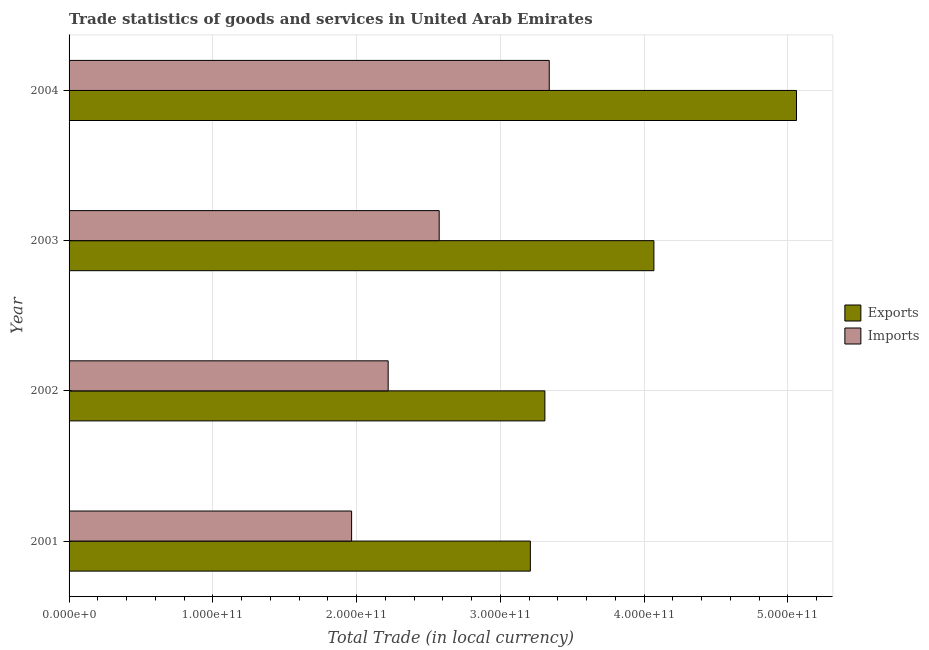Are the number of bars per tick equal to the number of legend labels?
Provide a succinct answer. Yes. In how many cases, is the number of bars for a given year not equal to the number of legend labels?
Your answer should be compact. 0. What is the imports of goods and services in 2003?
Your answer should be compact. 2.57e+11. Across all years, what is the maximum export of goods and services?
Offer a terse response. 5.06e+11. Across all years, what is the minimum imports of goods and services?
Ensure brevity in your answer.  1.97e+11. In which year was the export of goods and services maximum?
Your response must be concise. 2004. In which year was the export of goods and services minimum?
Provide a succinct answer. 2001. What is the total imports of goods and services in the graph?
Offer a terse response. 1.01e+12. What is the difference between the export of goods and services in 2002 and that in 2004?
Your answer should be very brief. -1.75e+11. What is the difference between the export of goods and services in 2002 and the imports of goods and services in 2004?
Provide a short and direct response. -3.03e+09. What is the average export of goods and services per year?
Provide a succinct answer. 3.91e+11. In the year 2003, what is the difference between the imports of goods and services and export of goods and services?
Provide a succinct answer. -1.49e+11. In how many years, is the imports of goods and services greater than 300000000000 LCU?
Your answer should be compact. 1. What is the ratio of the imports of goods and services in 2002 to that in 2004?
Your answer should be compact. 0.67. Is the imports of goods and services in 2002 less than that in 2004?
Keep it short and to the point. Yes. Is the difference between the imports of goods and services in 2003 and 2004 greater than the difference between the export of goods and services in 2003 and 2004?
Ensure brevity in your answer.  Yes. What is the difference between the highest and the second highest export of goods and services?
Your answer should be very brief. 9.92e+1. What is the difference between the highest and the lowest imports of goods and services?
Ensure brevity in your answer.  1.37e+11. What does the 1st bar from the top in 2004 represents?
Ensure brevity in your answer.  Imports. What does the 1st bar from the bottom in 2003 represents?
Ensure brevity in your answer.  Exports. What is the difference between two consecutive major ticks on the X-axis?
Ensure brevity in your answer.  1.00e+11. Does the graph contain any zero values?
Your answer should be compact. No. Does the graph contain grids?
Offer a very short reply. Yes. How are the legend labels stacked?
Offer a terse response. Vertical. What is the title of the graph?
Offer a very short reply. Trade statistics of goods and services in United Arab Emirates. What is the label or title of the X-axis?
Keep it short and to the point. Total Trade (in local currency). What is the Total Trade (in local currency) in Exports in 2001?
Your answer should be very brief. 3.21e+11. What is the Total Trade (in local currency) of Imports in 2001?
Your answer should be compact. 1.97e+11. What is the Total Trade (in local currency) of Exports in 2002?
Your response must be concise. 3.31e+11. What is the Total Trade (in local currency) of Imports in 2002?
Give a very brief answer. 2.22e+11. What is the Total Trade (in local currency) of Exports in 2003?
Provide a short and direct response. 4.07e+11. What is the Total Trade (in local currency) of Imports in 2003?
Give a very brief answer. 2.57e+11. What is the Total Trade (in local currency) of Exports in 2004?
Make the answer very short. 5.06e+11. What is the Total Trade (in local currency) of Imports in 2004?
Ensure brevity in your answer.  3.34e+11. Across all years, what is the maximum Total Trade (in local currency) in Exports?
Keep it short and to the point. 5.06e+11. Across all years, what is the maximum Total Trade (in local currency) of Imports?
Offer a terse response. 3.34e+11. Across all years, what is the minimum Total Trade (in local currency) in Exports?
Provide a short and direct response. 3.21e+11. Across all years, what is the minimum Total Trade (in local currency) in Imports?
Make the answer very short. 1.97e+11. What is the total Total Trade (in local currency) of Exports in the graph?
Offer a terse response. 1.56e+12. What is the total Total Trade (in local currency) in Imports in the graph?
Provide a short and direct response. 1.01e+12. What is the difference between the Total Trade (in local currency) of Exports in 2001 and that in 2002?
Your answer should be compact. -1.01e+1. What is the difference between the Total Trade (in local currency) in Imports in 2001 and that in 2002?
Make the answer very short. -2.54e+1. What is the difference between the Total Trade (in local currency) of Exports in 2001 and that in 2003?
Your answer should be very brief. -8.59e+1. What is the difference between the Total Trade (in local currency) of Imports in 2001 and that in 2003?
Offer a terse response. -6.09e+1. What is the difference between the Total Trade (in local currency) of Exports in 2001 and that in 2004?
Provide a succinct answer. -1.85e+11. What is the difference between the Total Trade (in local currency) of Imports in 2001 and that in 2004?
Your answer should be very brief. -1.37e+11. What is the difference between the Total Trade (in local currency) in Exports in 2002 and that in 2003?
Ensure brevity in your answer.  -7.58e+1. What is the difference between the Total Trade (in local currency) of Imports in 2002 and that in 2003?
Offer a very short reply. -3.55e+1. What is the difference between the Total Trade (in local currency) of Exports in 2002 and that in 2004?
Provide a short and direct response. -1.75e+11. What is the difference between the Total Trade (in local currency) in Imports in 2002 and that in 2004?
Give a very brief answer. -1.12e+11. What is the difference between the Total Trade (in local currency) of Exports in 2003 and that in 2004?
Provide a short and direct response. -9.92e+1. What is the difference between the Total Trade (in local currency) of Imports in 2003 and that in 2004?
Your answer should be very brief. -7.66e+1. What is the difference between the Total Trade (in local currency) of Exports in 2001 and the Total Trade (in local currency) of Imports in 2002?
Your answer should be very brief. 9.89e+1. What is the difference between the Total Trade (in local currency) of Exports in 2001 and the Total Trade (in local currency) of Imports in 2003?
Ensure brevity in your answer.  6.34e+1. What is the difference between the Total Trade (in local currency) in Exports in 2001 and the Total Trade (in local currency) in Imports in 2004?
Give a very brief answer. -1.31e+1. What is the difference between the Total Trade (in local currency) of Exports in 2002 and the Total Trade (in local currency) of Imports in 2003?
Give a very brief answer. 7.35e+1. What is the difference between the Total Trade (in local currency) in Exports in 2002 and the Total Trade (in local currency) in Imports in 2004?
Offer a very short reply. -3.03e+09. What is the difference between the Total Trade (in local currency) in Exports in 2003 and the Total Trade (in local currency) in Imports in 2004?
Make the answer very short. 7.28e+1. What is the average Total Trade (in local currency) of Exports per year?
Offer a very short reply. 3.91e+11. What is the average Total Trade (in local currency) in Imports per year?
Give a very brief answer. 2.52e+11. In the year 2001, what is the difference between the Total Trade (in local currency) of Exports and Total Trade (in local currency) of Imports?
Your response must be concise. 1.24e+11. In the year 2002, what is the difference between the Total Trade (in local currency) in Exports and Total Trade (in local currency) in Imports?
Your answer should be compact. 1.09e+11. In the year 2003, what is the difference between the Total Trade (in local currency) in Exports and Total Trade (in local currency) in Imports?
Your response must be concise. 1.49e+11. In the year 2004, what is the difference between the Total Trade (in local currency) in Exports and Total Trade (in local currency) in Imports?
Provide a succinct answer. 1.72e+11. What is the ratio of the Total Trade (in local currency) of Exports in 2001 to that in 2002?
Provide a succinct answer. 0.97. What is the ratio of the Total Trade (in local currency) in Imports in 2001 to that in 2002?
Ensure brevity in your answer.  0.89. What is the ratio of the Total Trade (in local currency) in Exports in 2001 to that in 2003?
Your answer should be compact. 0.79. What is the ratio of the Total Trade (in local currency) of Imports in 2001 to that in 2003?
Provide a short and direct response. 0.76. What is the ratio of the Total Trade (in local currency) in Exports in 2001 to that in 2004?
Provide a succinct answer. 0.63. What is the ratio of the Total Trade (in local currency) in Imports in 2001 to that in 2004?
Provide a short and direct response. 0.59. What is the ratio of the Total Trade (in local currency) of Exports in 2002 to that in 2003?
Provide a succinct answer. 0.81. What is the ratio of the Total Trade (in local currency) of Imports in 2002 to that in 2003?
Provide a short and direct response. 0.86. What is the ratio of the Total Trade (in local currency) in Exports in 2002 to that in 2004?
Your answer should be compact. 0.65. What is the ratio of the Total Trade (in local currency) in Imports in 2002 to that in 2004?
Ensure brevity in your answer.  0.66. What is the ratio of the Total Trade (in local currency) in Exports in 2003 to that in 2004?
Keep it short and to the point. 0.8. What is the ratio of the Total Trade (in local currency) in Imports in 2003 to that in 2004?
Keep it short and to the point. 0.77. What is the difference between the highest and the second highest Total Trade (in local currency) in Exports?
Keep it short and to the point. 9.92e+1. What is the difference between the highest and the second highest Total Trade (in local currency) in Imports?
Your answer should be very brief. 7.66e+1. What is the difference between the highest and the lowest Total Trade (in local currency) in Exports?
Your answer should be compact. 1.85e+11. What is the difference between the highest and the lowest Total Trade (in local currency) of Imports?
Ensure brevity in your answer.  1.37e+11. 